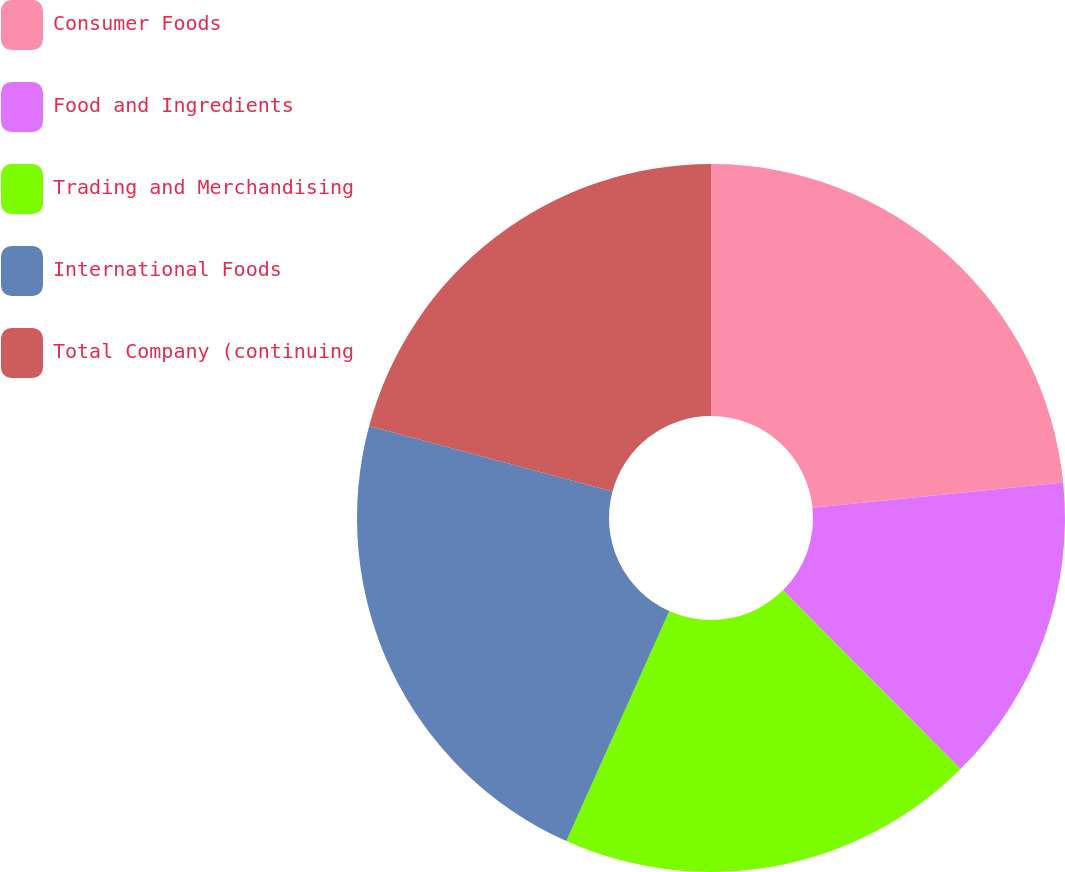Convert chart. <chart><loc_0><loc_0><loc_500><loc_500><pie_chart><fcel>Consumer Foods<fcel>Food and Ingredients<fcel>Trading and Merchandising<fcel>International Foods<fcel>Total Company (continuing<nl><fcel>23.4%<fcel>14.15%<fcel>19.15%<fcel>22.48%<fcel>20.82%<nl></chart> 